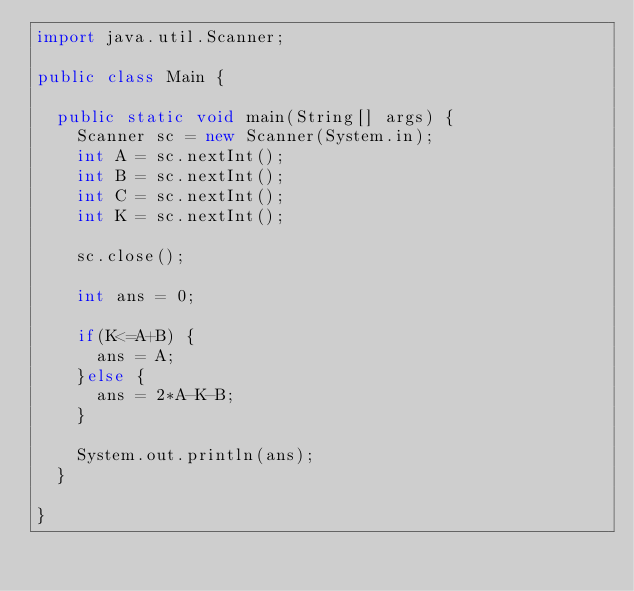<code> <loc_0><loc_0><loc_500><loc_500><_Java_>import java.util.Scanner;

public class Main {

	public static void main(String[] args) {
		Scanner sc = new Scanner(System.in);
		int A = sc.nextInt();
		int B = sc.nextInt();
		int C = sc.nextInt();
		int K = sc.nextInt();
		
		sc.close();
		
		int ans = 0;
		
		if(K<=A+B) {
			ans = A;
		}else {
			ans = 2*A-K-B;
		}
		
		System.out.println(ans);
	}

}</code> 